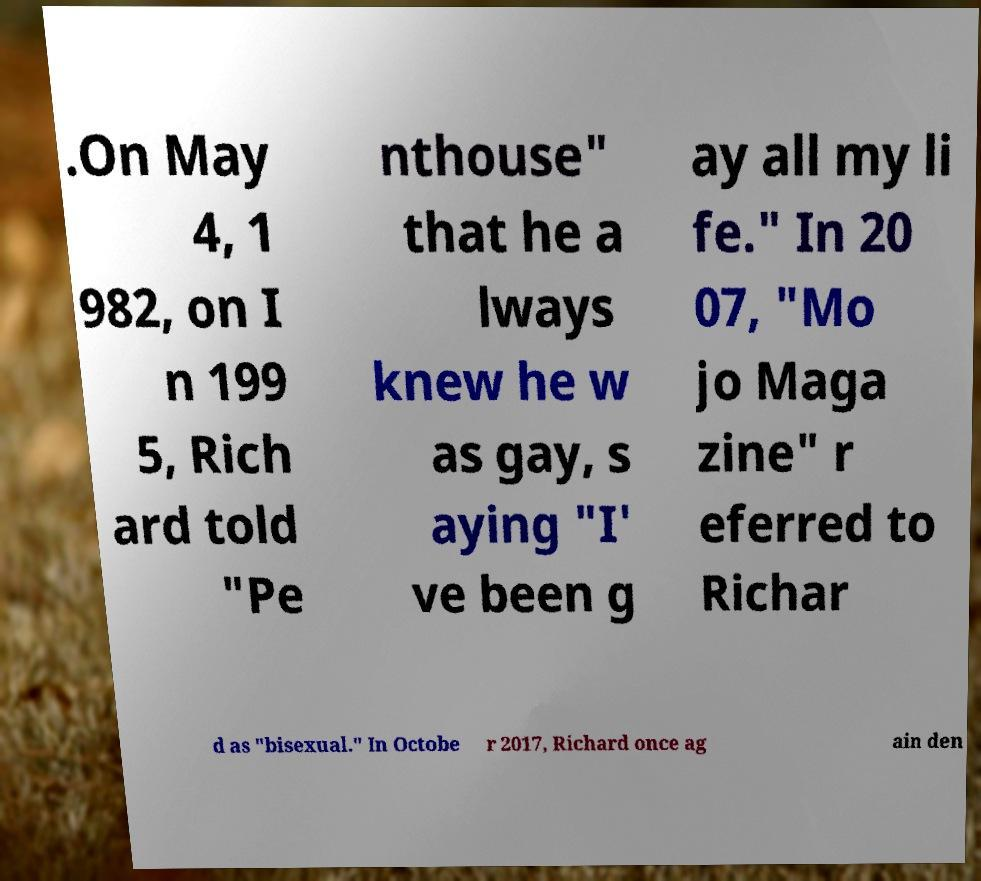What messages or text are displayed in this image? I need them in a readable, typed format. .On May 4, 1 982, on I n 199 5, Rich ard told "Pe nthouse" that he a lways knew he w as gay, s aying "I' ve been g ay all my li fe." In 20 07, "Mo jo Maga zine" r eferred to Richar d as "bisexual." In Octobe r 2017, Richard once ag ain den 